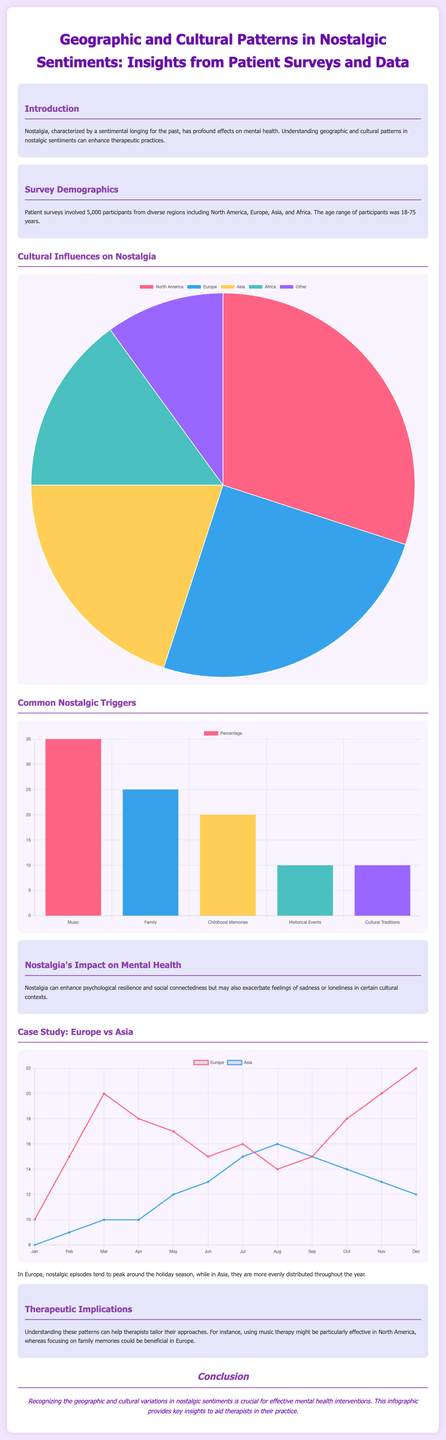what is the total number of participants in the survey? The total number of participants is mentioned as 5,000 in the document.
Answer: 5,000 which region has the highest percentage of nostalgic sentiments? The distribution data in the pie chart shows North America has the highest percentage at 30%.
Answer: North America what is the most common trigger for nostalgia according to the bar chart? The bar chart indicates that Music is the most common trigger for nostalgia, with a percentage of 35%.
Answer: Music what sentiment peaks around the holiday season in Europe? The document states that nostalgic episodes tend to peak around the holiday season in Europe.
Answer: Nostalgic episodes how many nostalgic episodes are recorded in Asia during January? The line chart shows that there are 8 nostalgic episodes recorded in Asia during January.
Answer: 8 what is the main therapeutic implication discussed in the document? The document discusses that understanding these patterns can help therapists tailor their approaches.
Answer: Tailor their approaches how does nostalgic sentiment vary between Europe and Asia? The document states that in Europe, nostalgic episodes peak around the holiday season, while in Asia, they are more evenly distributed throughout the year.
Answer: Peaks around the holiday season what percentage of participants identified Family as a nostalgic trigger? According to the bar chart, 25% of participants identified Family as a nostalgic trigger.
Answer: 25% 